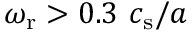Convert formula to latex. <formula><loc_0><loc_0><loc_500><loc_500>\omega _ { r } > 0 . 3 \ c _ { s } / a</formula> 